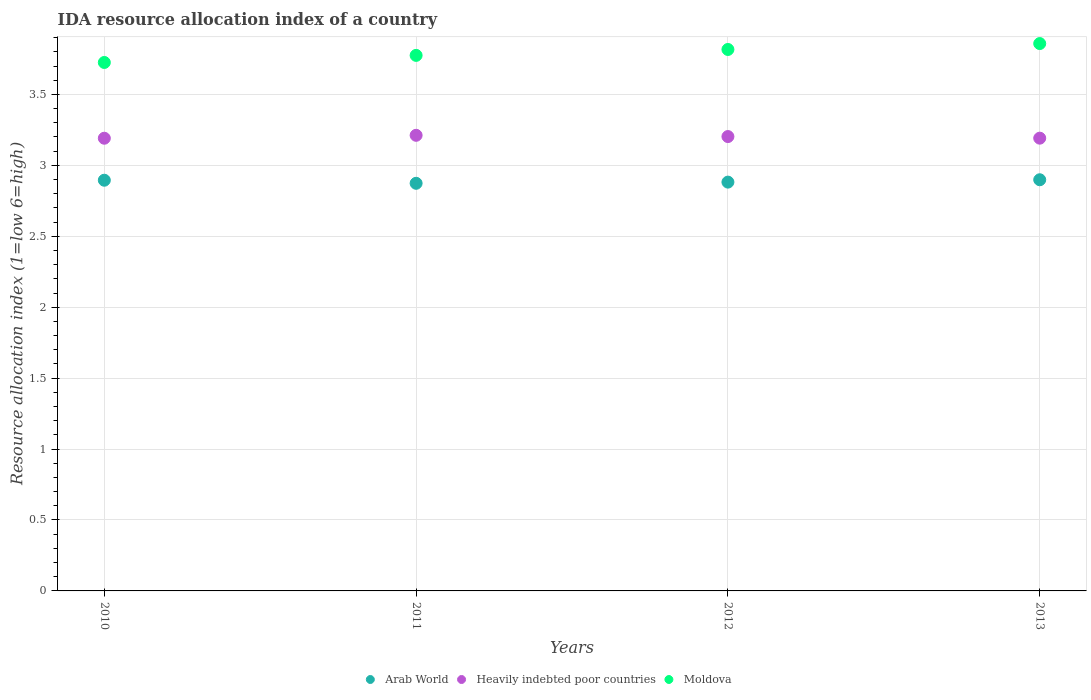How many different coloured dotlines are there?
Your answer should be compact. 3. Is the number of dotlines equal to the number of legend labels?
Your response must be concise. Yes. What is the IDA resource allocation index in Moldova in 2011?
Your response must be concise. 3.77. Across all years, what is the maximum IDA resource allocation index in Moldova?
Your answer should be very brief. 3.86. Across all years, what is the minimum IDA resource allocation index in Heavily indebted poor countries?
Keep it short and to the point. 3.19. In which year was the IDA resource allocation index in Moldova maximum?
Your response must be concise. 2013. What is the total IDA resource allocation index in Heavily indebted poor countries in the graph?
Ensure brevity in your answer.  12.8. What is the difference between the IDA resource allocation index in Moldova in 2010 and that in 2011?
Your answer should be very brief. -0.05. What is the difference between the IDA resource allocation index in Arab World in 2011 and the IDA resource allocation index in Moldova in 2012?
Give a very brief answer. -0.94. What is the average IDA resource allocation index in Arab World per year?
Keep it short and to the point. 2.89. In the year 2011, what is the difference between the IDA resource allocation index in Heavily indebted poor countries and IDA resource allocation index in Moldova?
Your answer should be compact. -0.56. In how many years, is the IDA resource allocation index in Moldova greater than 0.1?
Your answer should be very brief. 4. What is the ratio of the IDA resource allocation index in Arab World in 2011 to that in 2013?
Provide a succinct answer. 0.99. Is the difference between the IDA resource allocation index in Heavily indebted poor countries in 2011 and 2012 greater than the difference between the IDA resource allocation index in Moldova in 2011 and 2012?
Offer a very short reply. Yes. What is the difference between the highest and the second highest IDA resource allocation index in Arab World?
Provide a succinct answer. 0. What is the difference between the highest and the lowest IDA resource allocation index in Heavily indebted poor countries?
Provide a short and direct response. 0.02. Is it the case that in every year, the sum of the IDA resource allocation index in Arab World and IDA resource allocation index in Heavily indebted poor countries  is greater than the IDA resource allocation index in Moldova?
Your answer should be very brief. Yes. Does the IDA resource allocation index in Arab World monotonically increase over the years?
Your response must be concise. No. How many dotlines are there?
Your answer should be compact. 3. Are the values on the major ticks of Y-axis written in scientific E-notation?
Provide a succinct answer. No. Does the graph contain any zero values?
Your answer should be very brief. No. How many legend labels are there?
Provide a succinct answer. 3. What is the title of the graph?
Offer a terse response. IDA resource allocation index of a country. Does "Bangladesh" appear as one of the legend labels in the graph?
Your answer should be compact. No. What is the label or title of the X-axis?
Your answer should be compact. Years. What is the label or title of the Y-axis?
Give a very brief answer. Resource allocation index (1=low 6=high). What is the Resource allocation index (1=low 6=high) in Arab World in 2010?
Ensure brevity in your answer.  2.9. What is the Resource allocation index (1=low 6=high) of Heavily indebted poor countries in 2010?
Offer a terse response. 3.19. What is the Resource allocation index (1=low 6=high) of Moldova in 2010?
Keep it short and to the point. 3.73. What is the Resource allocation index (1=low 6=high) in Arab World in 2011?
Make the answer very short. 2.87. What is the Resource allocation index (1=low 6=high) in Heavily indebted poor countries in 2011?
Your answer should be compact. 3.21. What is the Resource allocation index (1=low 6=high) in Moldova in 2011?
Provide a succinct answer. 3.77. What is the Resource allocation index (1=low 6=high) of Arab World in 2012?
Provide a short and direct response. 2.88. What is the Resource allocation index (1=low 6=high) in Heavily indebted poor countries in 2012?
Provide a short and direct response. 3.2. What is the Resource allocation index (1=low 6=high) in Moldova in 2012?
Make the answer very short. 3.82. What is the Resource allocation index (1=low 6=high) in Arab World in 2013?
Your answer should be compact. 2.9. What is the Resource allocation index (1=low 6=high) in Heavily indebted poor countries in 2013?
Keep it short and to the point. 3.19. What is the Resource allocation index (1=low 6=high) in Moldova in 2013?
Your answer should be very brief. 3.86. Across all years, what is the maximum Resource allocation index (1=low 6=high) of Arab World?
Your answer should be very brief. 2.9. Across all years, what is the maximum Resource allocation index (1=low 6=high) of Heavily indebted poor countries?
Make the answer very short. 3.21. Across all years, what is the maximum Resource allocation index (1=low 6=high) in Moldova?
Give a very brief answer. 3.86. Across all years, what is the minimum Resource allocation index (1=low 6=high) of Arab World?
Your response must be concise. 2.87. Across all years, what is the minimum Resource allocation index (1=low 6=high) of Heavily indebted poor countries?
Keep it short and to the point. 3.19. Across all years, what is the minimum Resource allocation index (1=low 6=high) in Moldova?
Keep it short and to the point. 3.73. What is the total Resource allocation index (1=low 6=high) in Arab World in the graph?
Offer a very short reply. 11.55. What is the total Resource allocation index (1=low 6=high) in Heavily indebted poor countries in the graph?
Offer a terse response. 12.8. What is the total Resource allocation index (1=low 6=high) in Moldova in the graph?
Provide a short and direct response. 15.18. What is the difference between the Resource allocation index (1=low 6=high) of Arab World in 2010 and that in 2011?
Your answer should be very brief. 0.02. What is the difference between the Resource allocation index (1=low 6=high) of Heavily indebted poor countries in 2010 and that in 2011?
Provide a succinct answer. -0.02. What is the difference between the Resource allocation index (1=low 6=high) in Arab World in 2010 and that in 2012?
Offer a terse response. 0.01. What is the difference between the Resource allocation index (1=low 6=high) of Heavily indebted poor countries in 2010 and that in 2012?
Your answer should be compact. -0.01. What is the difference between the Resource allocation index (1=low 6=high) of Moldova in 2010 and that in 2012?
Ensure brevity in your answer.  -0.09. What is the difference between the Resource allocation index (1=low 6=high) in Arab World in 2010 and that in 2013?
Provide a short and direct response. -0. What is the difference between the Resource allocation index (1=low 6=high) of Heavily indebted poor countries in 2010 and that in 2013?
Make the answer very short. -0. What is the difference between the Resource allocation index (1=low 6=high) of Moldova in 2010 and that in 2013?
Ensure brevity in your answer.  -0.13. What is the difference between the Resource allocation index (1=low 6=high) of Arab World in 2011 and that in 2012?
Make the answer very short. -0.01. What is the difference between the Resource allocation index (1=low 6=high) in Heavily indebted poor countries in 2011 and that in 2012?
Give a very brief answer. 0.01. What is the difference between the Resource allocation index (1=low 6=high) of Moldova in 2011 and that in 2012?
Offer a very short reply. -0.04. What is the difference between the Resource allocation index (1=low 6=high) of Arab World in 2011 and that in 2013?
Provide a succinct answer. -0.03. What is the difference between the Resource allocation index (1=low 6=high) of Heavily indebted poor countries in 2011 and that in 2013?
Offer a very short reply. 0.02. What is the difference between the Resource allocation index (1=low 6=high) of Moldova in 2011 and that in 2013?
Keep it short and to the point. -0.08. What is the difference between the Resource allocation index (1=low 6=high) of Arab World in 2012 and that in 2013?
Your answer should be compact. -0.02. What is the difference between the Resource allocation index (1=low 6=high) in Heavily indebted poor countries in 2012 and that in 2013?
Make the answer very short. 0.01. What is the difference between the Resource allocation index (1=low 6=high) of Moldova in 2012 and that in 2013?
Keep it short and to the point. -0.04. What is the difference between the Resource allocation index (1=low 6=high) in Arab World in 2010 and the Resource allocation index (1=low 6=high) in Heavily indebted poor countries in 2011?
Ensure brevity in your answer.  -0.32. What is the difference between the Resource allocation index (1=low 6=high) of Arab World in 2010 and the Resource allocation index (1=low 6=high) of Moldova in 2011?
Offer a terse response. -0.88. What is the difference between the Resource allocation index (1=low 6=high) in Heavily indebted poor countries in 2010 and the Resource allocation index (1=low 6=high) in Moldova in 2011?
Ensure brevity in your answer.  -0.58. What is the difference between the Resource allocation index (1=low 6=high) in Arab World in 2010 and the Resource allocation index (1=low 6=high) in Heavily indebted poor countries in 2012?
Your response must be concise. -0.31. What is the difference between the Resource allocation index (1=low 6=high) of Arab World in 2010 and the Resource allocation index (1=low 6=high) of Moldova in 2012?
Your answer should be very brief. -0.92. What is the difference between the Resource allocation index (1=low 6=high) of Heavily indebted poor countries in 2010 and the Resource allocation index (1=low 6=high) of Moldova in 2012?
Give a very brief answer. -0.63. What is the difference between the Resource allocation index (1=low 6=high) of Arab World in 2010 and the Resource allocation index (1=low 6=high) of Heavily indebted poor countries in 2013?
Provide a short and direct response. -0.3. What is the difference between the Resource allocation index (1=low 6=high) of Arab World in 2010 and the Resource allocation index (1=low 6=high) of Moldova in 2013?
Make the answer very short. -0.96. What is the difference between the Resource allocation index (1=low 6=high) of Heavily indebted poor countries in 2010 and the Resource allocation index (1=low 6=high) of Moldova in 2013?
Offer a terse response. -0.67. What is the difference between the Resource allocation index (1=low 6=high) of Arab World in 2011 and the Resource allocation index (1=low 6=high) of Heavily indebted poor countries in 2012?
Ensure brevity in your answer.  -0.33. What is the difference between the Resource allocation index (1=low 6=high) of Arab World in 2011 and the Resource allocation index (1=low 6=high) of Moldova in 2012?
Keep it short and to the point. -0.94. What is the difference between the Resource allocation index (1=low 6=high) in Heavily indebted poor countries in 2011 and the Resource allocation index (1=low 6=high) in Moldova in 2012?
Provide a succinct answer. -0.6. What is the difference between the Resource allocation index (1=low 6=high) in Arab World in 2011 and the Resource allocation index (1=low 6=high) in Heavily indebted poor countries in 2013?
Give a very brief answer. -0.32. What is the difference between the Resource allocation index (1=low 6=high) in Arab World in 2011 and the Resource allocation index (1=low 6=high) in Moldova in 2013?
Give a very brief answer. -0.98. What is the difference between the Resource allocation index (1=low 6=high) in Heavily indebted poor countries in 2011 and the Resource allocation index (1=low 6=high) in Moldova in 2013?
Provide a succinct answer. -0.65. What is the difference between the Resource allocation index (1=low 6=high) in Arab World in 2012 and the Resource allocation index (1=low 6=high) in Heavily indebted poor countries in 2013?
Your response must be concise. -0.31. What is the difference between the Resource allocation index (1=low 6=high) of Arab World in 2012 and the Resource allocation index (1=low 6=high) of Moldova in 2013?
Give a very brief answer. -0.98. What is the difference between the Resource allocation index (1=low 6=high) in Heavily indebted poor countries in 2012 and the Resource allocation index (1=low 6=high) in Moldova in 2013?
Your answer should be compact. -0.66. What is the average Resource allocation index (1=low 6=high) of Arab World per year?
Your response must be concise. 2.89. What is the average Resource allocation index (1=low 6=high) of Heavily indebted poor countries per year?
Make the answer very short. 3.2. What is the average Resource allocation index (1=low 6=high) of Moldova per year?
Your answer should be compact. 3.79. In the year 2010, what is the difference between the Resource allocation index (1=low 6=high) of Arab World and Resource allocation index (1=low 6=high) of Heavily indebted poor countries?
Your response must be concise. -0.3. In the year 2010, what is the difference between the Resource allocation index (1=low 6=high) of Arab World and Resource allocation index (1=low 6=high) of Moldova?
Give a very brief answer. -0.83. In the year 2010, what is the difference between the Resource allocation index (1=low 6=high) in Heavily indebted poor countries and Resource allocation index (1=low 6=high) in Moldova?
Give a very brief answer. -0.53. In the year 2011, what is the difference between the Resource allocation index (1=low 6=high) in Arab World and Resource allocation index (1=low 6=high) in Heavily indebted poor countries?
Provide a short and direct response. -0.34. In the year 2011, what is the difference between the Resource allocation index (1=low 6=high) in Arab World and Resource allocation index (1=low 6=high) in Moldova?
Offer a terse response. -0.9. In the year 2011, what is the difference between the Resource allocation index (1=low 6=high) in Heavily indebted poor countries and Resource allocation index (1=low 6=high) in Moldova?
Your response must be concise. -0.56. In the year 2012, what is the difference between the Resource allocation index (1=low 6=high) in Arab World and Resource allocation index (1=low 6=high) in Heavily indebted poor countries?
Keep it short and to the point. -0.32. In the year 2012, what is the difference between the Resource allocation index (1=low 6=high) in Arab World and Resource allocation index (1=low 6=high) in Moldova?
Make the answer very short. -0.94. In the year 2012, what is the difference between the Resource allocation index (1=low 6=high) of Heavily indebted poor countries and Resource allocation index (1=low 6=high) of Moldova?
Your response must be concise. -0.61. In the year 2013, what is the difference between the Resource allocation index (1=low 6=high) in Arab World and Resource allocation index (1=low 6=high) in Heavily indebted poor countries?
Offer a terse response. -0.29. In the year 2013, what is the difference between the Resource allocation index (1=low 6=high) in Arab World and Resource allocation index (1=low 6=high) in Moldova?
Provide a succinct answer. -0.96. In the year 2013, what is the difference between the Resource allocation index (1=low 6=high) in Heavily indebted poor countries and Resource allocation index (1=low 6=high) in Moldova?
Give a very brief answer. -0.67. What is the ratio of the Resource allocation index (1=low 6=high) in Arab World in 2010 to that in 2011?
Offer a terse response. 1.01. What is the ratio of the Resource allocation index (1=low 6=high) in Heavily indebted poor countries in 2010 to that in 2011?
Your answer should be compact. 0.99. What is the ratio of the Resource allocation index (1=low 6=high) in Moldova in 2010 to that in 2011?
Your answer should be compact. 0.99. What is the ratio of the Resource allocation index (1=low 6=high) in Arab World in 2010 to that in 2012?
Provide a succinct answer. 1. What is the ratio of the Resource allocation index (1=low 6=high) of Moldova in 2010 to that in 2012?
Give a very brief answer. 0.98. What is the ratio of the Resource allocation index (1=low 6=high) of Arab World in 2010 to that in 2013?
Provide a succinct answer. 1. What is the ratio of the Resource allocation index (1=low 6=high) of Moldova in 2010 to that in 2013?
Your answer should be very brief. 0.97. What is the ratio of the Resource allocation index (1=low 6=high) of Arab World in 2011 to that in 2012?
Ensure brevity in your answer.  1. What is the ratio of the Resource allocation index (1=low 6=high) of Arab World in 2011 to that in 2013?
Provide a short and direct response. 0.99. What is the ratio of the Resource allocation index (1=low 6=high) in Heavily indebted poor countries in 2011 to that in 2013?
Provide a short and direct response. 1.01. What is the ratio of the Resource allocation index (1=low 6=high) of Moldova in 2011 to that in 2013?
Provide a short and direct response. 0.98. What is the ratio of the Resource allocation index (1=low 6=high) in Heavily indebted poor countries in 2012 to that in 2013?
Your answer should be compact. 1. What is the difference between the highest and the second highest Resource allocation index (1=low 6=high) in Arab World?
Your answer should be very brief. 0. What is the difference between the highest and the second highest Resource allocation index (1=low 6=high) of Heavily indebted poor countries?
Give a very brief answer. 0.01. What is the difference between the highest and the second highest Resource allocation index (1=low 6=high) in Moldova?
Your response must be concise. 0.04. What is the difference between the highest and the lowest Resource allocation index (1=low 6=high) of Arab World?
Offer a terse response. 0.03. What is the difference between the highest and the lowest Resource allocation index (1=low 6=high) in Heavily indebted poor countries?
Offer a terse response. 0.02. What is the difference between the highest and the lowest Resource allocation index (1=low 6=high) of Moldova?
Ensure brevity in your answer.  0.13. 